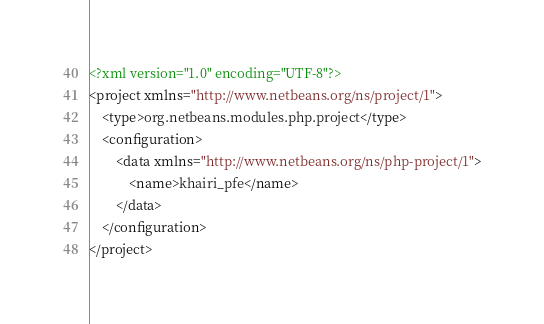<code> <loc_0><loc_0><loc_500><loc_500><_XML_><?xml version="1.0" encoding="UTF-8"?>
<project xmlns="http://www.netbeans.org/ns/project/1">
    <type>org.netbeans.modules.php.project</type>
    <configuration>
        <data xmlns="http://www.netbeans.org/ns/php-project/1">
            <name>khairi_pfe</name>
        </data>
    </configuration>
</project>
</code> 